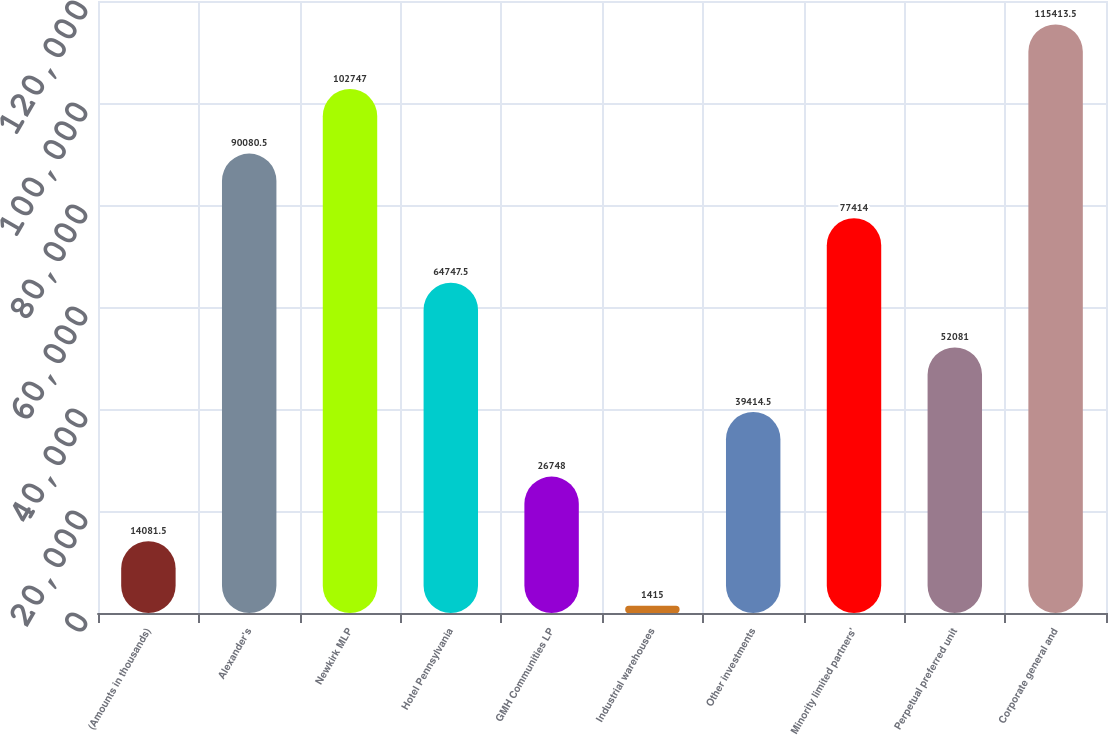<chart> <loc_0><loc_0><loc_500><loc_500><bar_chart><fcel>(Amounts in thousands)<fcel>Alexander's<fcel>Newkirk MLP<fcel>Hotel Pennsylvania<fcel>GMH Communities LP<fcel>Industrial warehouses<fcel>Other investments<fcel>Minority limited partners'<fcel>Perpetual preferred unit<fcel>Corporate general and<nl><fcel>14081.5<fcel>90080.5<fcel>102747<fcel>64747.5<fcel>26748<fcel>1415<fcel>39414.5<fcel>77414<fcel>52081<fcel>115414<nl></chart> 